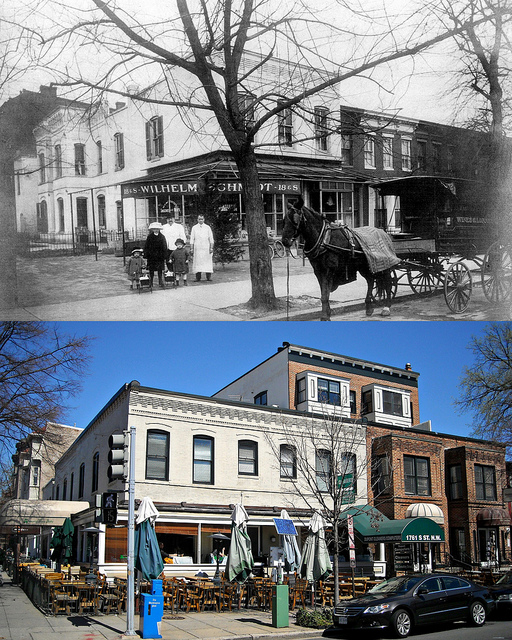Please transcribe the text in this image. WILHELM 